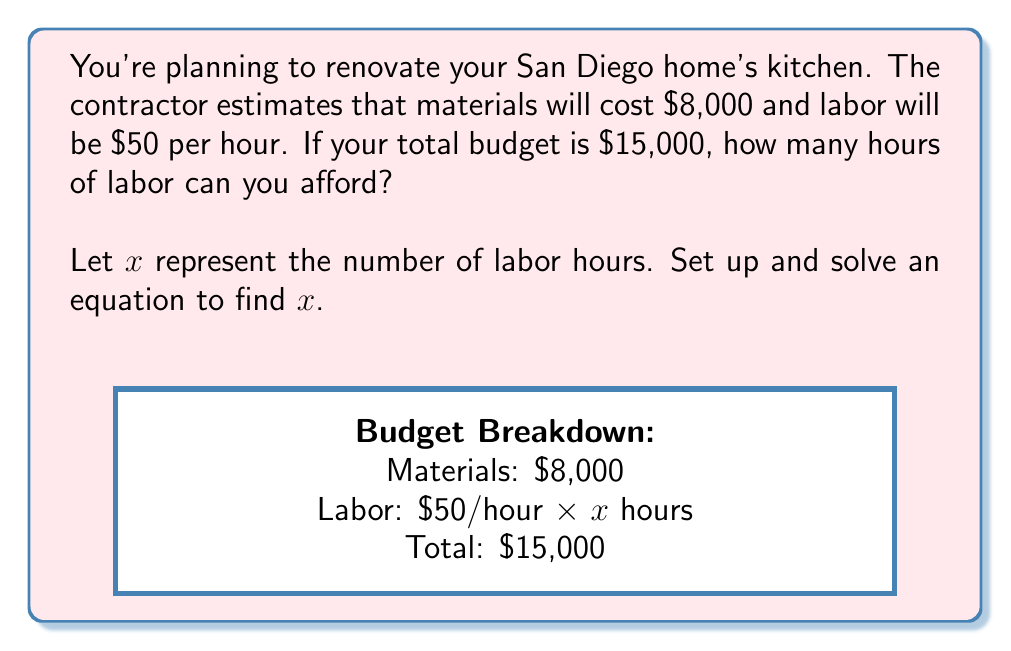Solve this math problem. Let's approach this step-by-step:

1) First, let's define our variables:
   $x$ = number of labor hours
   Cost of materials = $8,000
   Labor cost per hour = $50
   Total budget = $15,000

2) Now, we can set up an equation:
   Cost of materials + (Labor cost per hour × Number of hours) = Total budget
   $8000 + 50x = 15000$

3) To solve for $x$, let's first subtract $8000 from both sides:
   $50x = 15000 - 8000$
   $50x = 7000$

4) Now, divide both sides by 50:
   $x = 7000 ÷ 50$
   $x = 140$

Therefore, you can afford 140 hours of labor.

5) Let's verify:
   $8000 + (50 × 140) = 8000 + 7000 = 15000$
   This matches our total budget, confirming our solution.
Answer: 140 hours 